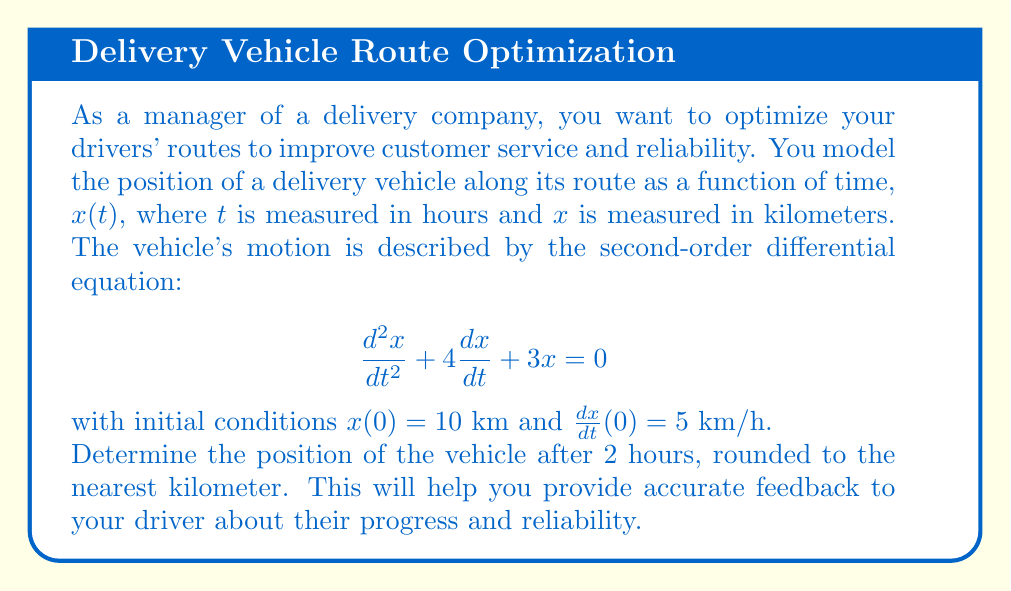Can you answer this question? To solve this problem, we'll follow these steps:

1) The given differential equation is a second-order linear homogeneous equation with constant coefficients. Its characteristic equation is:

   $$r^2 + 4r + 3 = 0$$

2) Solving this quadratic equation:
   $$r = \frac{-4 \pm \sqrt{16 - 12}}{2} = \frac{-4 \pm 2}{2}$$
   $$r_1 = -1, r_2 = -3$$

3) The general solution is therefore:
   $$x(t) = c_1e^{-t} + c_2e^{-3t}$$

4) To find $c_1$ and $c_2$, we use the initial conditions:

   $x(0) = 10$: $c_1 + c_2 = 10$
   
   $\frac{dx}{dt}(0) = 5$: $-c_1 - 3c_2 = 5$

5) Solving this system of equations:
   $c_1 = 15$, $c_2 = -5$

6) Therefore, the particular solution is:
   $$x(t) = 15e^{-t} - 5e^{-3t}$$

7) To find the position after 2 hours, we evaluate $x(2)$:
   $$x(2) = 15e^{-2} - 5e^{-6}$$

8) Calculating this:
   $$x(2) \approx 15(0.1353) - 5(0.0025) \approx 2.0295 - 0.0125 \approx 2.017$$

9) Rounding to the nearest kilometer:
   $$x(2) \approx 2 \text{ km}$$
Answer: 2 km 